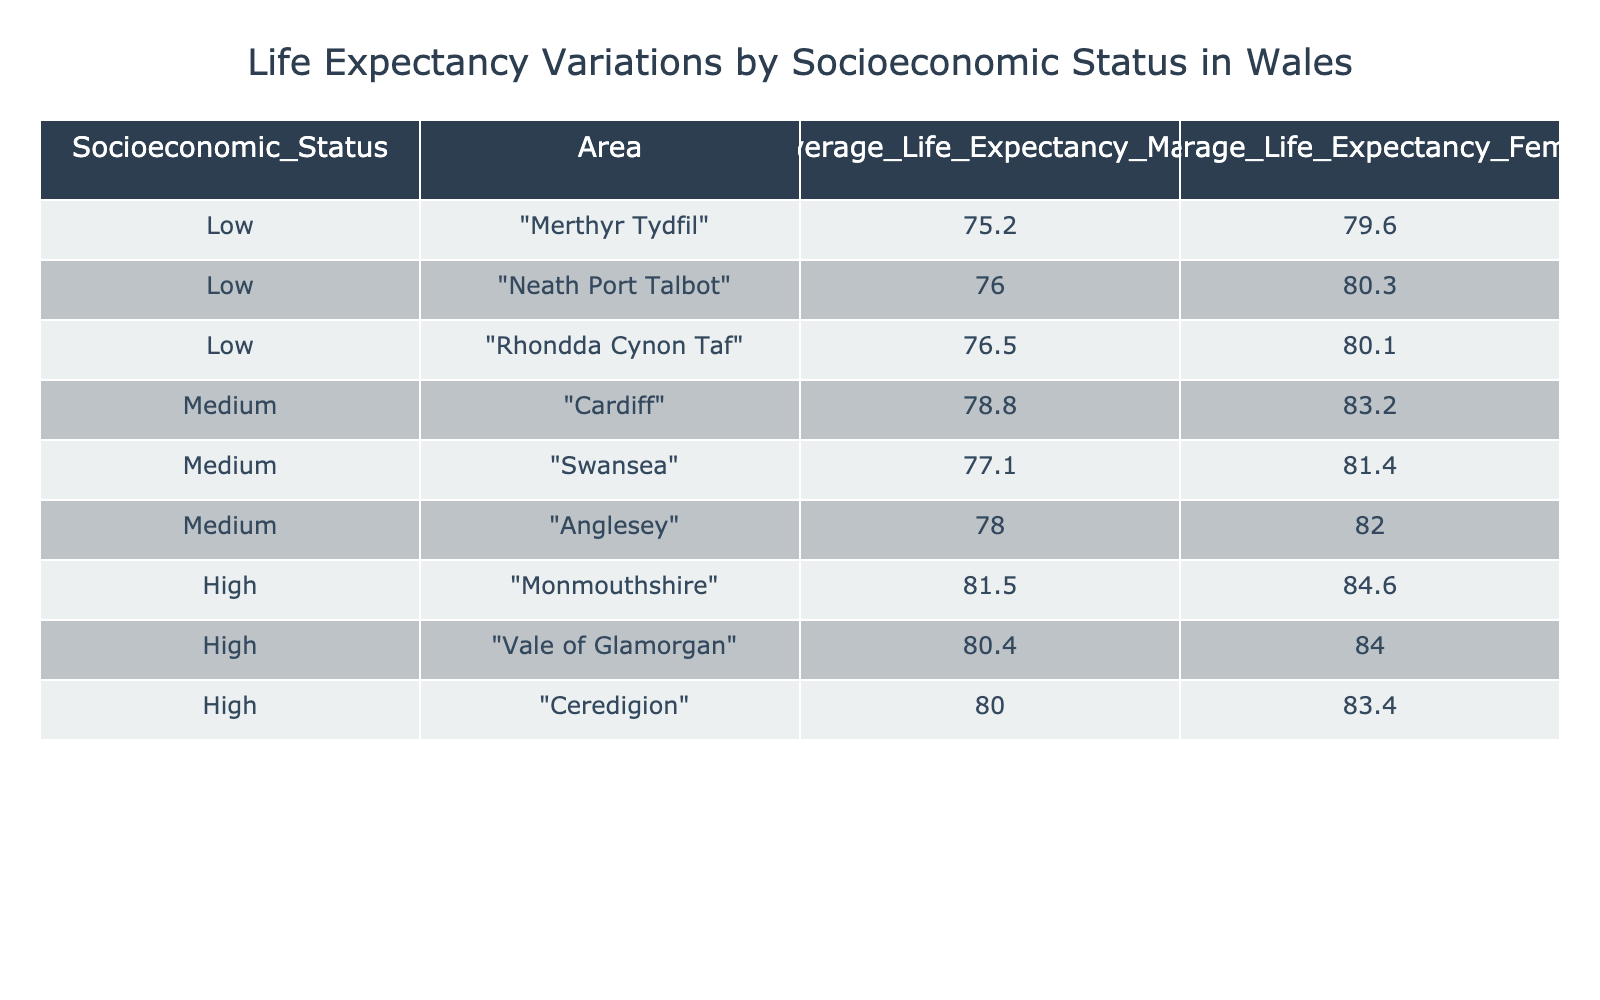What is the average life expectancy for males in Monmouthshire? The table lists the average life expectancy for males in Monmouthshire as 81.5 years.
Answer: 81.5 Which area has the highest average life expectancy for females? By comparing the average life expectancy for females across areas, Monmouthshire is found to have the highest value at 84.6 years.
Answer: 84.6 Is the average life expectancy for females in Rhondda Cynon Taf greater than that in Neath Port Talbot? The average life expectancy for females in Rhondda Cynon Taf is 80.1 years, while in Neath Port Talbot it is 80.3 years. Thus, Rhondda Cynon Taf's life expectancy is lower than Neath Port Talbot's.
Answer: No What is the difference in average life expectancy for males between high and low socioeconomic status? The average life expectancy for males in high socioeconomic status areas (average of 81.5, 80.4, and 80.0 = 80.67) minus the average for low socioeconomic status areas (average of 75.2, 76.0, and 76.5 = 75.57) equals 80.67 - 75.57 = 5.1 years.
Answer: 5.1 Which socioeconomic group has the lowest average life expectancy for males? The low socioeconomic status group has the lowest average life expectancy for males, at 75.2 years in Merthyr Tydfil.
Answer: Low What is the average life expectancy for females in medium socioeconomic areas? The average life expectancy for females in medium socioeconomic areas is calculated as (83.2 + 81.4 + 82.0) / 3 = 82.2 years.
Answer: 82.2 Are females in Anglesey expected to live longer than females in Vale of Glamorgan? The average life expectancy for females in Anglesey is 82.0 years, while in the Vale of Glamorgan it is 84.0 years. Hence, females in Anglesey are not expected to live longer.
Answer: No What is the total average life expectancy for males across all socioeconomic categories? Summing the average male life expectancies: (75.2 + 76.0 + 76.5 + 78.8 + 77.1 + 78.0 + 81.5 + 80.4 + 80.0) gives a total of 785.5 years. Dividing by the number of areas (9) gives 785.5 / 9 = 87.28 years.
Answer: 87.28 